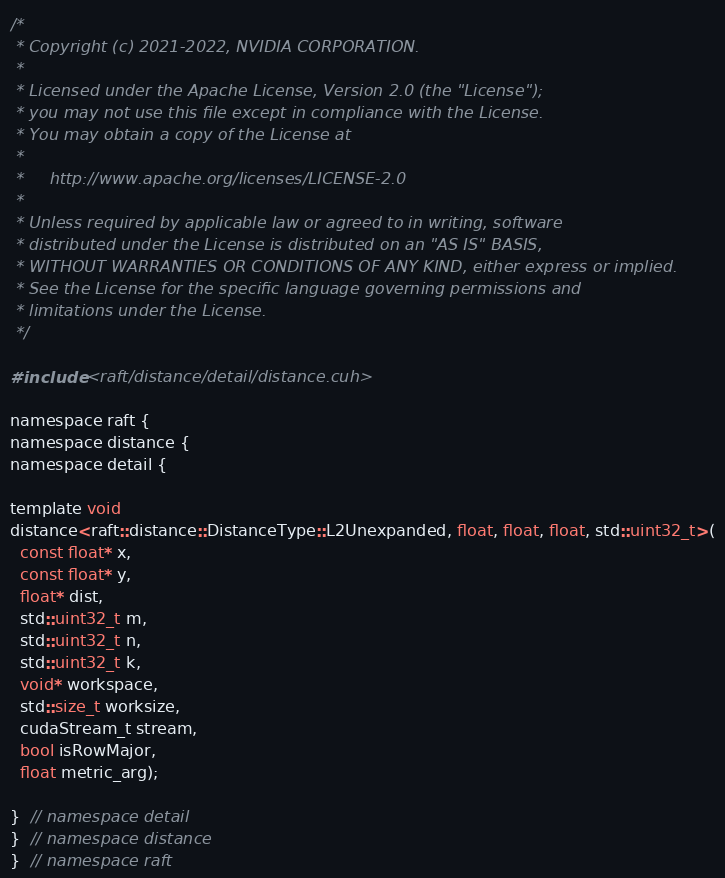<code> <loc_0><loc_0><loc_500><loc_500><_Cuda_>/*
 * Copyright (c) 2021-2022, NVIDIA CORPORATION.
 *
 * Licensed under the Apache License, Version 2.0 (the "License");
 * you may not use this file except in compliance with the License.
 * You may obtain a copy of the License at
 *
 *     http://www.apache.org/licenses/LICENSE-2.0
 *
 * Unless required by applicable law or agreed to in writing, software
 * distributed under the License is distributed on an "AS IS" BASIS,
 * WITHOUT WARRANTIES OR CONDITIONS OF ANY KIND, either express or implied.
 * See the License for the specific language governing permissions and
 * limitations under the License.
 */

#include <raft/distance/detail/distance.cuh>

namespace raft {
namespace distance {
namespace detail {

template void
distance<raft::distance::DistanceType::L2Unexpanded, float, float, float, std::uint32_t>(
  const float* x,
  const float* y,
  float* dist,
  std::uint32_t m,
  std::uint32_t n,
  std::uint32_t k,
  void* workspace,
  std::size_t worksize,
  cudaStream_t stream,
  bool isRowMajor,
  float metric_arg);

}  // namespace detail
}  // namespace distance
}  // namespace raft
</code> 